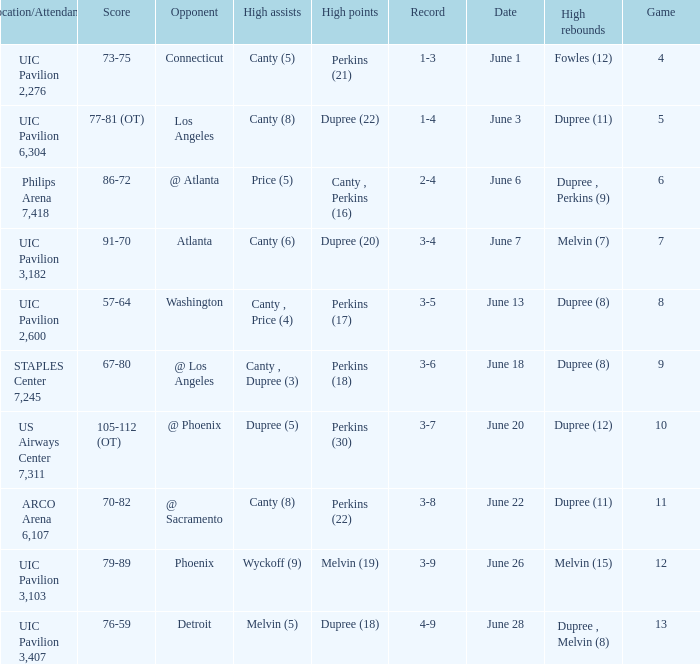Who had the most assists in the game that led to a 3-7 record? Dupree (5). Could you help me parse every detail presented in this table? {'header': ['Location/Attendance', 'Score', 'Opponent', 'High assists', 'High points', 'Record', 'Date', 'High rebounds', 'Game'], 'rows': [['UIC Pavilion 2,276', '73-75', 'Connecticut', 'Canty (5)', 'Perkins (21)', '1-3', 'June 1', 'Fowles (12)', '4'], ['UIC Pavilion 6,304', '77-81 (OT)', 'Los Angeles', 'Canty (8)', 'Dupree (22)', '1-4', 'June 3', 'Dupree (11)', '5'], ['Philips Arena 7,418', '86-72', '@ Atlanta', 'Price (5)', 'Canty , Perkins (16)', '2-4', 'June 6', 'Dupree , Perkins (9)', '6'], ['UIC Pavilion 3,182', '91-70', 'Atlanta', 'Canty (6)', 'Dupree (20)', '3-4', 'June 7', 'Melvin (7)', '7'], ['UIC Pavilion 2,600', '57-64', 'Washington', 'Canty , Price (4)', 'Perkins (17)', '3-5', 'June 13', 'Dupree (8)', '8'], ['STAPLES Center 7,245', '67-80', '@ Los Angeles', 'Canty , Dupree (3)', 'Perkins (18)', '3-6', 'June 18', 'Dupree (8)', '9'], ['US Airways Center 7,311', '105-112 (OT)', '@ Phoenix', 'Dupree (5)', 'Perkins (30)', '3-7', 'June 20', 'Dupree (12)', '10'], ['ARCO Arena 6,107', '70-82', '@ Sacramento', 'Canty (8)', 'Perkins (22)', '3-8', 'June 22', 'Dupree (11)', '11'], ['UIC Pavilion 3,103', '79-89', 'Phoenix', 'Wyckoff (9)', 'Melvin (19)', '3-9', 'June 26', 'Melvin (15)', '12'], ['UIC Pavilion 3,407', '76-59', 'Detroit', 'Melvin (5)', 'Dupree (18)', '4-9', 'June 28', 'Dupree , Melvin (8)', '13']]} 